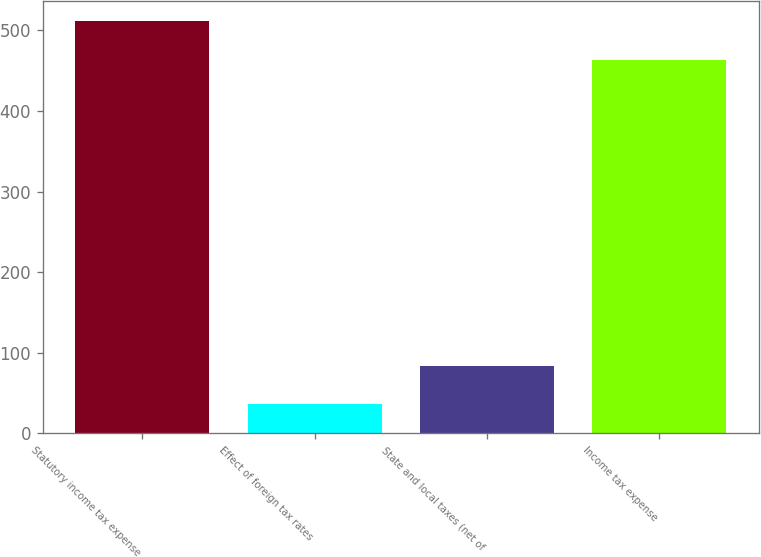Convert chart to OTSL. <chart><loc_0><loc_0><loc_500><loc_500><bar_chart><fcel>Statutory income tax expense<fcel>Effect of foreign tax rates<fcel>State and local taxes (net of<fcel>Income tax expense<nl><fcel>511.5<fcel>36<fcel>83.5<fcel>464<nl></chart> 